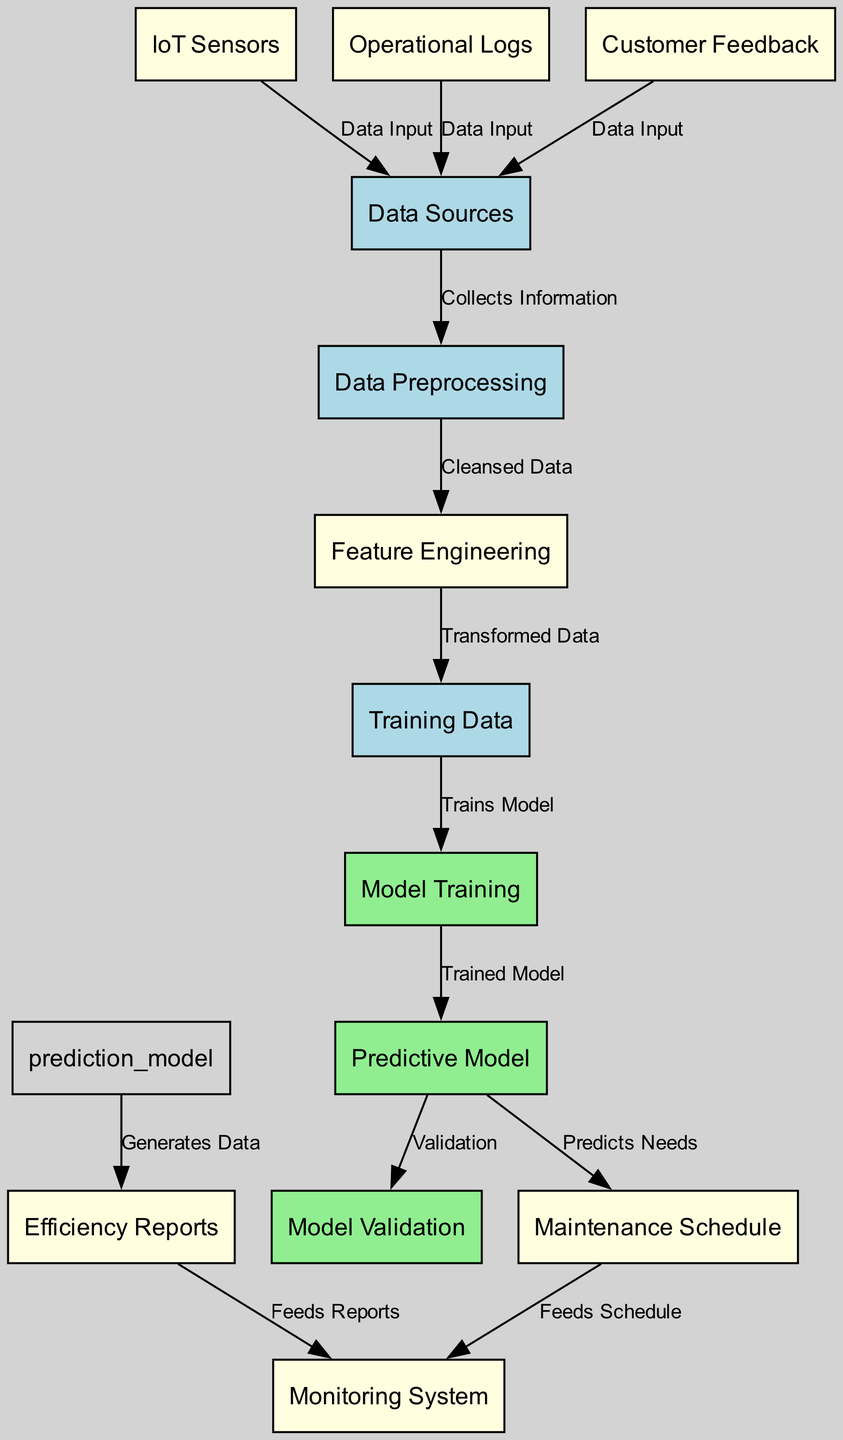What is the initial step to gather data in the diagram? The initial step is represented by the node labeled "Data Sources," where various inputs for the system are collected. This node connects to "Data Preprocessing," indicating the first stage of the process after collecting data.
Answer: Data Sources How many data inputs are represented in the diagram? The diagram lists three distinct data input nodes: "IoT Sensors," "Operational Logs," and "Customer Feedback." Each of these nodes feeds data into "Data Sources."
Answer: Three Which node follows "Feature Engineering" in the flow? Following "Feature Engineering," the next step in the flow is "Training Data," indicating the transformed data prepared for model training. This can be seen by the directed edge from "Feature Engineering" to "Training Data."
Answer: Training Data What is the output of the "Predictive Model"? The "Predictive Model" generates outputs for two nodes: "Maintenance Schedule" and "Efficiency Reports," as indicated by the edges originating from the model.
Answer: Maintenance Schedule, Efficiency Reports Which node receives the "Cleansed Data"? The node that receives the "Cleansed Data" from "Data Preprocessing" is "Feature Engineering," where data is transformed before training the model. This direction is shown by the edge connecting these nodes.
Answer: Feature Engineering What does the "Maintenance Schedule" feed into? The "Maintenance Schedule" feeds into the "Monitoring System," which is shown through the directed edge connecting these two nodes, indicating that maintenance schedules are crucial for continuous monitoring.
Answer: Monitoring System What stage comes before "Model Validation"? The stage that comes before "Model Validation" is "Predictive Model." This relationship is established through the directed edge indicating that the predictive model must be validated after its training is complete.
Answer: Predictive Model How do "Efficiency Reports" relate to the "Monitoring System"? "Efficiency Reports" feed data into the "Monitoring System," providing insights and performance measures as part of the ongoing monitoring process, as indicated by the directed edge connecting these two nodes.
Answer: Feeds Reports 